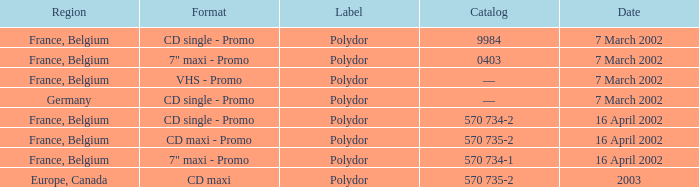Which region had a release format of CD Maxi? Europe, Canada. 